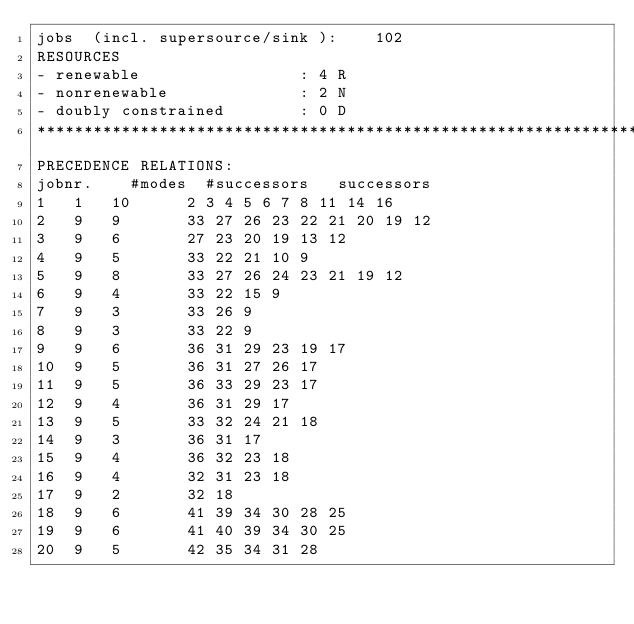Convert code to text. <code><loc_0><loc_0><loc_500><loc_500><_ObjectiveC_>jobs  (incl. supersource/sink ):	102
RESOURCES
- renewable                 : 4 R
- nonrenewable              : 2 N
- doubly constrained        : 0 D
************************************************************************
PRECEDENCE RELATIONS:
jobnr.    #modes  #successors   successors
1	1	10		2 3 4 5 6 7 8 11 14 16 
2	9	9		33 27 26 23 22 21 20 19 12 
3	9	6		27 23 20 19 13 12 
4	9	5		33 22 21 10 9 
5	9	8		33 27 26 24 23 21 19 12 
6	9	4		33 22 15 9 
7	9	3		33 26 9 
8	9	3		33 22 9 
9	9	6		36 31 29 23 19 17 
10	9	5		36 31 27 26 17 
11	9	5		36 33 29 23 17 
12	9	4		36 31 29 17 
13	9	5		33 32 24 21 18 
14	9	3		36 31 17 
15	9	4		36 32 23 18 
16	9	4		32 31 23 18 
17	9	2		32 18 
18	9	6		41 39 34 30 28 25 
19	9	6		41 40 39 34 30 25 
20	9	5		42 35 34 31 28 </code> 